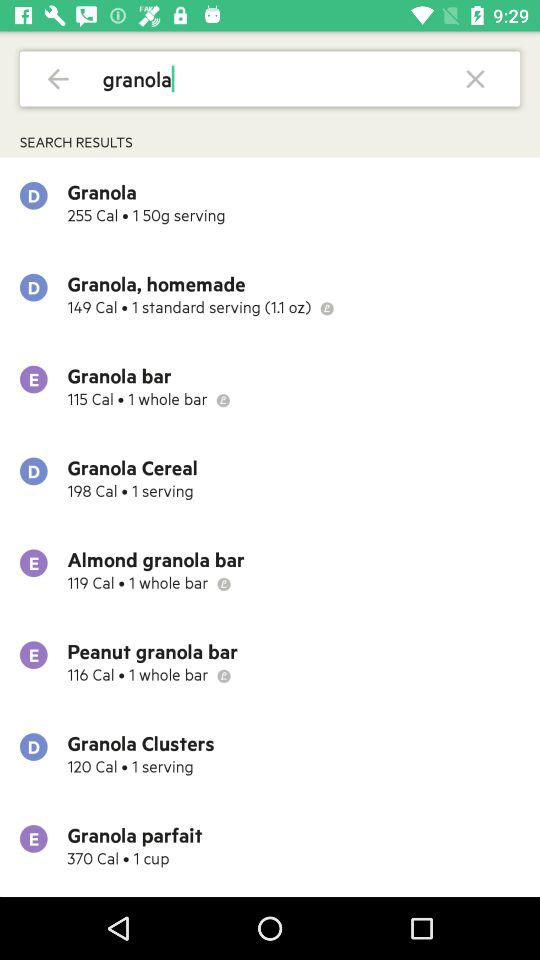How many calories are there in the "Granola bar"? There are 115 calories. 